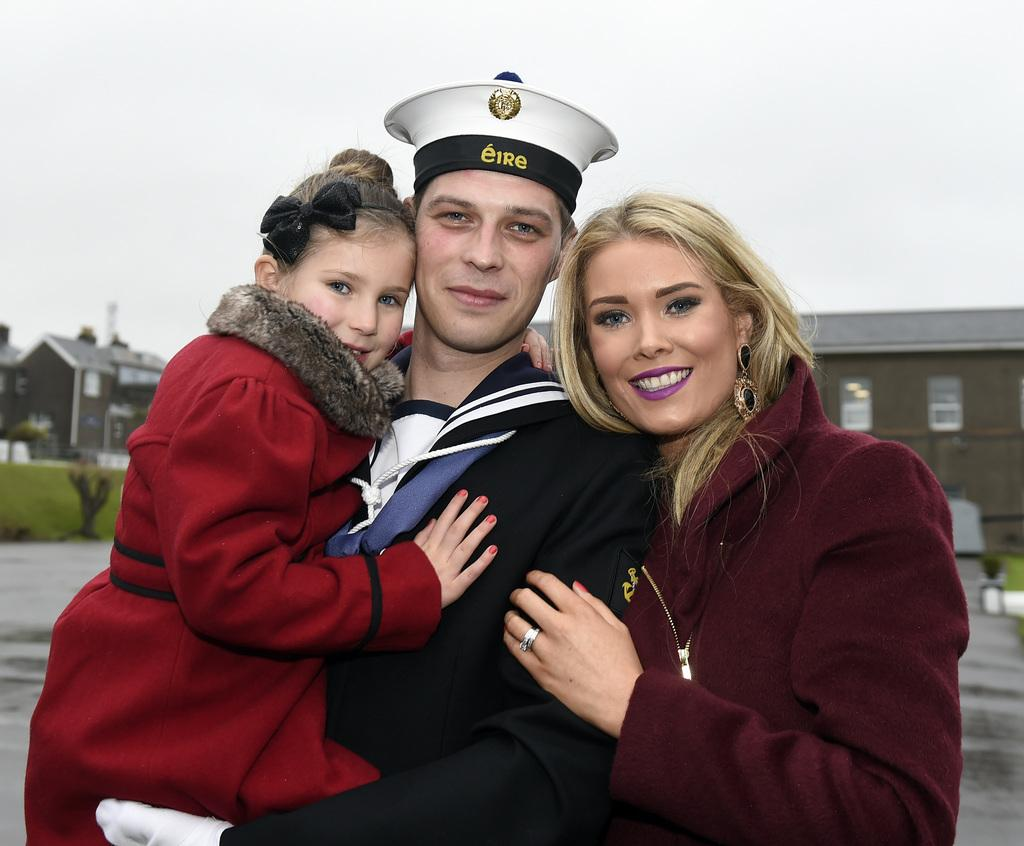How many people are in the image? There are three people in the image: a man, a woman, and a child. What are the people in the image wearing? The man, woman, and child are wearing jackets. What can be seen in the background of the image? There is a house in the background of the image. What is at the bottom of the image? There is a road at the bottom of the image. What is visible at the top of the image? The sky is visible at the top of the image. What type of pleasure can be seen being experienced by the door in the image? There is no door present in the image, and therefore no pleasure can be experienced by it. 